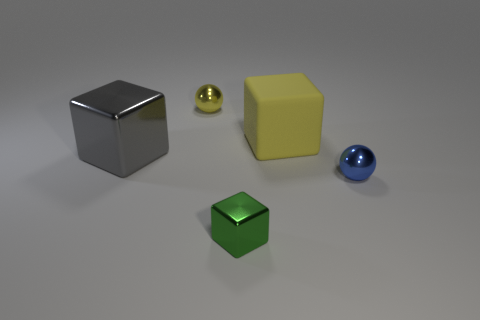Subtract all red cubes. Subtract all green balls. How many cubes are left? 3 Add 2 blue objects. How many objects exist? 7 Subtract all cubes. How many objects are left? 2 Add 5 small yellow balls. How many small yellow balls exist? 6 Subtract 0 cyan blocks. How many objects are left? 5 Subtract all small metal balls. Subtract all big green rubber cylinders. How many objects are left? 3 Add 3 large gray shiny objects. How many large gray shiny objects are left? 4 